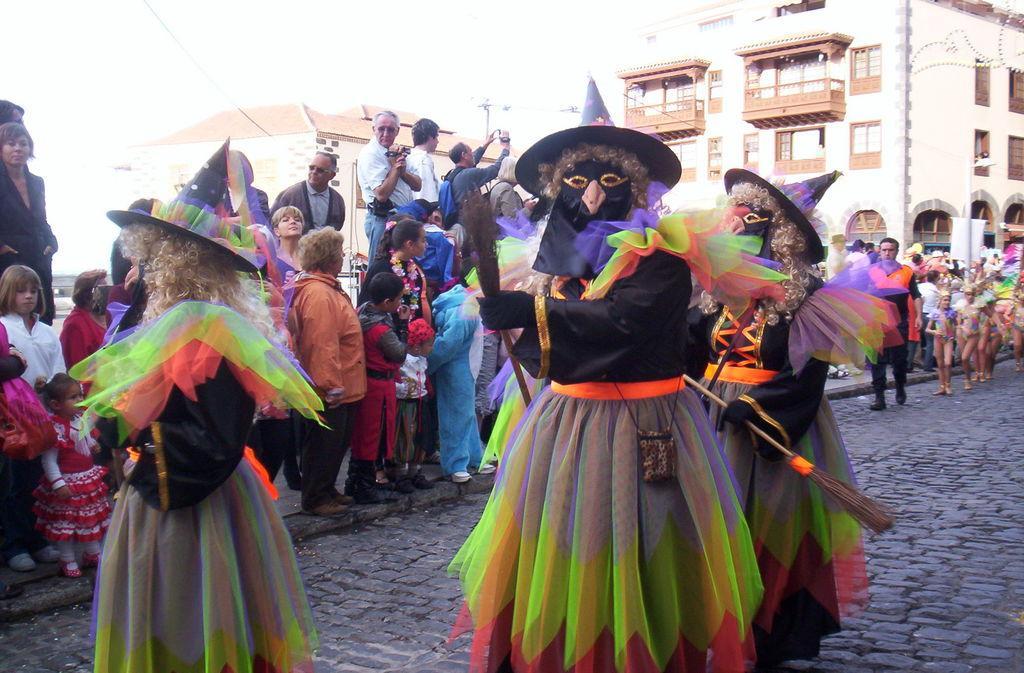Please provide a concise description of this image. In this image it seems like a carnival in which there are three people in the middle who are wearing the costume and holding the broomstick. In the background there are so many people standing on the footpath and watching them. On the right side top corner there is a building. In the middle there are few people who are taking the pictures with the camera. On the right side there are few people who are walking on the floor by wearing different costumes. 